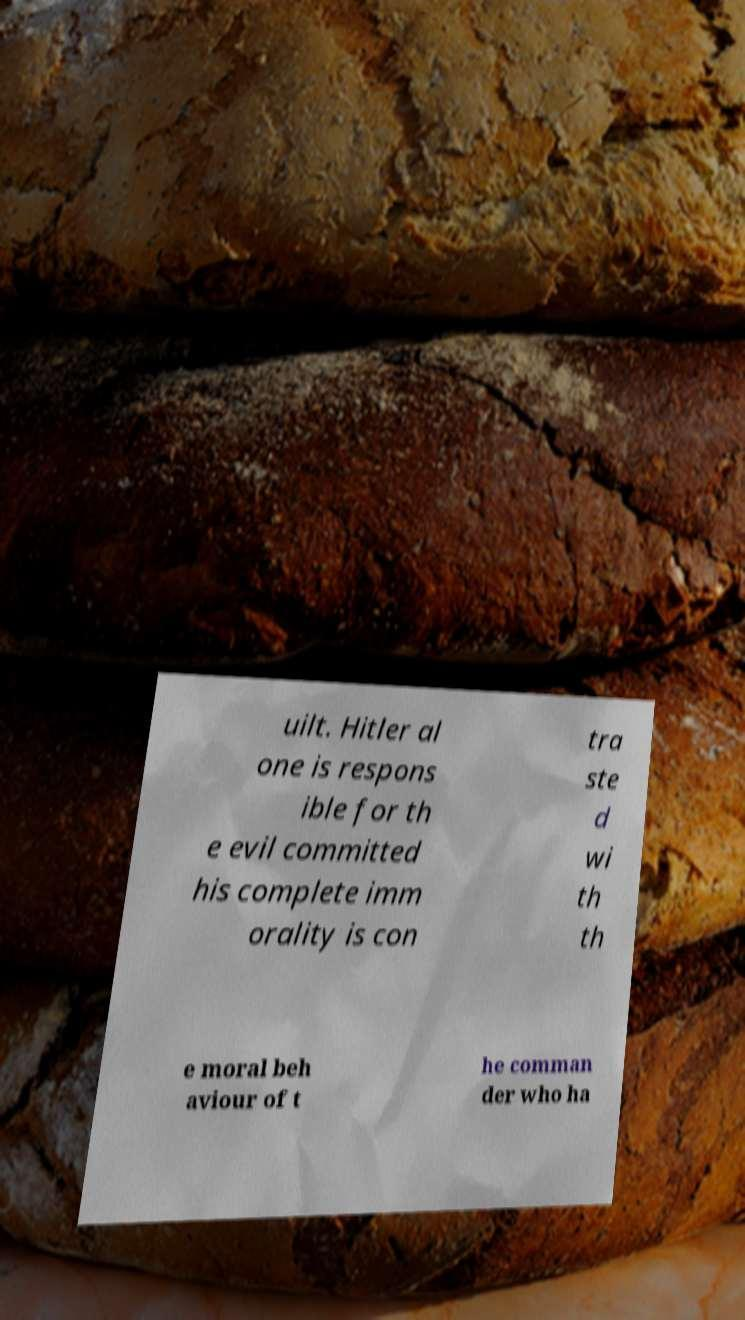For documentation purposes, I need the text within this image transcribed. Could you provide that? uilt. Hitler al one is respons ible for th e evil committed his complete imm orality is con tra ste d wi th th e moral beh aviour of t he comman der who ha 